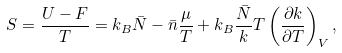Convert formula to latex. <formula><loc_0><loc_0><loc_500><loc_500>S = \frac { U - F } { T } = k _ { B } \bar { N } - \bar { n } \frac { \mu } { T } + k _ { B } \frac { \bar { N } } { k } T \left ( \frac { \partial k } { \partial T } \right ) _ { V } ,</formula> 